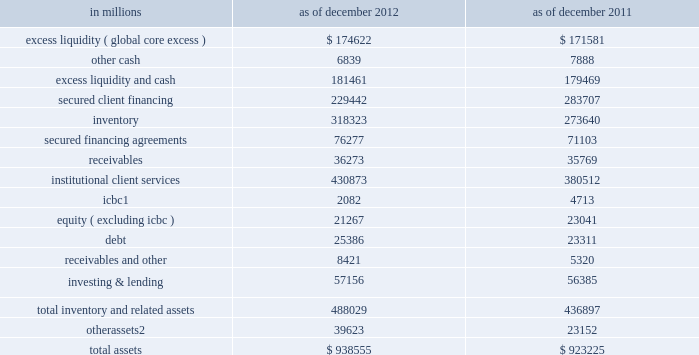Management 2019s discussion and analysis business-specific limits .
The firmwide finance committee sets asset and liability limits for each business and aged inventory limits for certain financial instruments as a disincentive to hold inventory over longer periods of time .
These limits are set at levels which are close to actual operating levels in order to ensure prompt escalation and discussion among business managers and managers in our independent control and support functions on a routine basis .
The firmwide finance committee reviews and approves balance sheet limits on a quarterly basis and may also approve changes in limits on an ad hoc basis in response to changing business needs or market conditions .
Monitoring of key metrics .
We monitor key balance sheet metrics daily both by business and on a consolidated basis , including asset and liability size and composition , aged inventory , limit utilization , risk measures and capital usage .
We allocate assets to businesses and review and analyze movements resulting from new business activity as well as market fluctuations .
Scenario analyses .
We conduct scenario analyses to determine how we would manage the size and composition of our balance sheet and maintain appropriate funding , liquidity and capital positions in a variety of situations : 2030 these scenarios cover short-term and long-term time horizons using various macro-economic and firm-specific assumptions .
We use these analyses to assist us in developing longer-term funding plans , including the level of unsecured debt issuances , the size of our secured funding program and the amount and composition of our equity capital .
We also consider any potential future constraints , such as limits on our ability to grow our asset base in the absence of appropriate funding .
2030 through our internal capital adequacy assessment process ( icaap ) , ccar , the stress tests we are required to conduct under the dodd-frank act , and our resolution and recovery planning , we further analyze how we would manage our balance sheet and risks through the duration of a severe crisis and we develop plans to access funding , generate liquidity , and/or redeploy or issue equity capital , as appropriate .
Balance sheet allocation in addition to preparing our consolidated statements of financial condition in accordance with u.s .
Gaap , we prepare a balance sheet that generally allocates assets to our businesses , which is a non-gaap presentation and may not be comparable to similar non-gaap presentations used by other companies .
We believe that presenting our assets on this basis is meaningful because it is consistent with the way management views and manages risks associated with the firm 2019s assets and better enables investors to assess the liquidity of the firm 2019s assets .
The table below presents a summary of this balance sheet allocation. .
In january 2013 , we sold approximately 45% ( 45 % ) of our ordinary shares of icbc .
Includes assets related to our reinsurance business classified as held for sale as of december 2012 .
See note 12 to the consolidated financial statements for further information .
62 goldman sachs 2012 annual report .
What is the debt-to-asset ratio in 2012? 
Computations: (25386 / 938555)
Answer: 0.02705. 